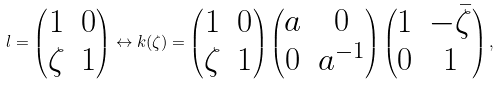Convert formula to latex. <formula><loc_0><loc_0><loc_500><loc_500>l = \left ( \begin{matrix} 1 & 0 \\ \zeta & 1 \end{matrix} \right ) \leftrightarrow k ( \zeta ) = \left ( \begin{matrix} 1 & 0 \\ \zeta & 1 \end{matrix} \right ) \left ( \begin{matrix} a & 0 \\ 0 & a ^ { - 1 } \end{matrix} \right ) \left ( \begin{matrix} 1 & - \bar { \zeta } \\ 0 & 1 \end{matrix} \right ) ,</formula> 